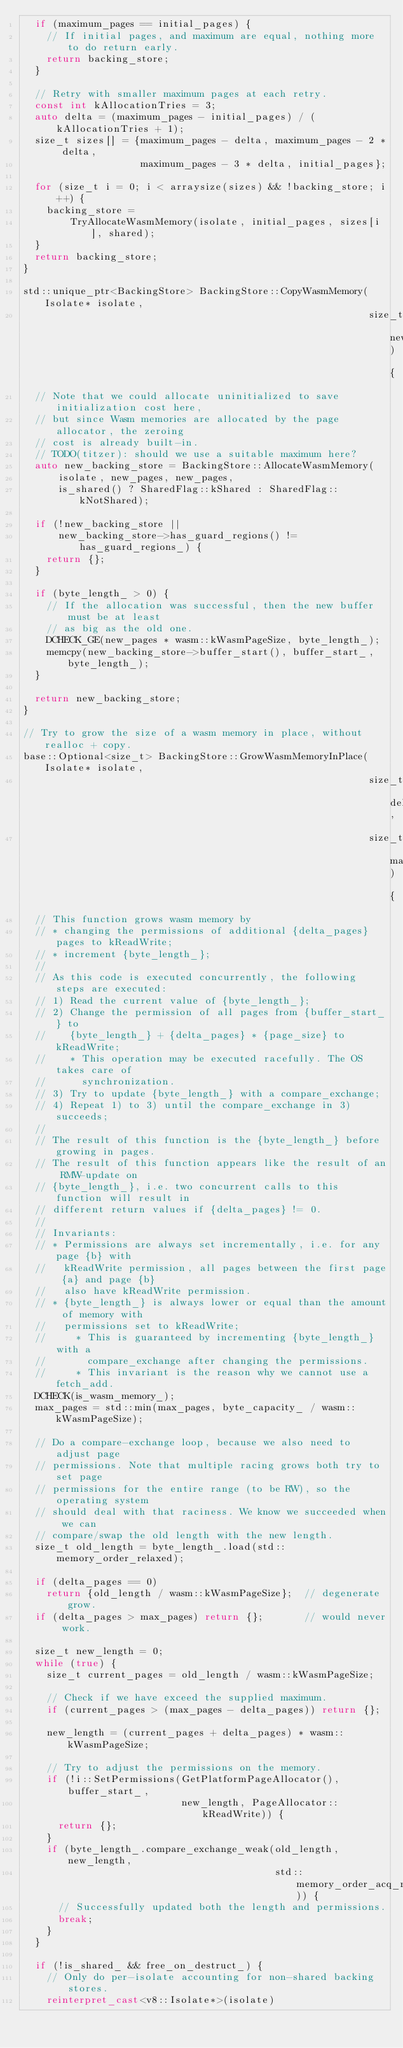Convert code to text. <code><loc_0><loc_0><loc_500><loc_500><_C++_>  if (maximum_pages == initial_pages) {
    // If initial pages, and maximum are equal, nothing more to do return early.
    return backing_store;
  }

  // Retry with smaller maximum pages at each retry.
  const int kAllocationTries = 3;
  auto delta = (maximum_pages - initial_pages) / (kAllocationTries + 1);
  size_t sizes[] = {maximum_pages - delta, maximum_pages - 2 * delta,
                    maximum_pages - 3 * delta, initial_pages};

  for (size_t i = 0; i < arraysize(sizes) && !backing_store; i++) {
    backing_store =
        TryAllocateWasmMemory(isolate, initial_pages, sizes[i], shared);
  }
  return backing_store;
}

std::unique_ptr<BackingStore> BackingStore::CopyWasmMemory(Isolate* isolate,
                                                           size_t new_pages) {
  // Note that we could allocate uninitialized to save initialization cost here,
  // but since Wasm memories are allocated by the page allocator, the zeroing
  // cost is already built-in.
  // TODO(titzer): should we use a suitable maximum here?
  auto new_backing_store = BackingStore::AllocateWasmMemory(
      isolate, new_pages, new_pages,
      is_shared() ? SharedFlag::kShared : SharedFlag::kNotShared);

  if (!new_backing_store ||
      new_backing_store->has_guard_regions() != has_guard_regions_) {
    return {};
  }

  if (byte_length_ > 0) {
    // If the allocation was successful, then the new buffer must be at least
    // as big as the old one.
    DCHECK_GE(new_pages * wasm::kWasmPageSize, byte_length_);
    memcpy(new_backing_store->buffer_start(), buffer_start_, byte_length_);
  }

  return new_backing_store;
}

// Try to grow the size of a wasm memory in place, without realloc + copy.
base::Optional<size_t> BackingStore::GrowWasmMemoryInPlace(Isolate* isolate,
                                                           size_t delta_pages,
                                                           size_t max_pages) {
  // This function grows wasm memory by
  // * changing the permissions of additional {delta_pages} pages to kReadWrite;
  // * increment {byte_length_};
  //
  // As this code is executed concurrently, the following steps are executed:
  // 1) Read the current value of {byte_length_};
  // 2) Change the permission of all pages from {buffer_start_} to
  //    {byte_length_} + {delta_pages} * {page_size} to kReadWrite;
  //    * This operation may be executed racefully. The OS takes care of
  //      synchronization.
  // 3) Try to update {byte_length_} with a compare_exchange;
  // 4) Repeat 1) to 3) until the compare_exchange in 3) succeeds;
  //
  // The result of this function is the {byte_length_} before growing in pages.
  // The result of this function appears like the result of an RMW-update on
  // {byte_length_}, i.e. two concurrent calls to this function will result in
  // different return values if {delta_pages} != 0.
  //
  // Invariants:
  // * Permissions are always set incrementally, i.e. for any page {b} with
  //   kReadWrite permission, all pages between the first page {a} and page {b}
  //   also have kReadWrite permission.
  // * {byte_length_} is always lower or equal than the amount of memory with
  //   permissions set to kReadWrite;
  //     * This is guaranteed by incrementing {byte_length_} with a
  //       compare_exchange after changing the permissions.
  //     * This invariant is the reason why we cannot use a fetch_add.
  DCHECK(is_wasm_memory_);
  max_pages = std::min(max_pages, byte_capacity_ / wasm::kWasmPageSize);

  // Do a compare-exchange loop, because we also need to adjust page
  // permissions. Note that multiple racing grows both try to set page
  // permissions for the entire range (to be RW), so the operating system
  // should deal with that raciness. We know we succeeded when we can
  // compare/swap the old length with the new length.
  size_t old_length = byte_length_.load(std::memory_order_relaxed);

  if (delta_pages == 0)
    return {old_length / wasm::kWasmPageSize};  // degenerate grow.
  if (delta_pages > max_pages) return {};       // would never work.

  size_t new_length = 0;
  while (true) {
    size_t current_pages = old_length / wasm::kWasmPageSize;

    // Check if we have exceed the supplied maximum.
    if (current_pages > (max_pages - delta_pages)) return {};

    new_length = (current_pages + delta_pages) * wasm::kWasmPageSize;

    // Try to adjust the permissions on the memory.
    if (!i::SetPermissions(GetPlatformPageAllocator(), buffer_start_,
                           new_length, PageAllocator::kReadWrite)) {
      return {};
    }
    if (byte_length_.compare_exchange_weak(old_length, new_length,
                                           std::memory_order_acq_rel)) {
      // Successfully updated both the length and permissions.
      break;
    }
  }

  if (!is_shared_ && free_on_destruct_) {
    // Only do per-isolate accounting for non-shared backing stores.
    reinterpret_cast<v8::Isolate*>(isolate)</code> 